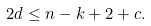Convert formula to latex. <formula><loc_0><loc_0><loc_500><loc_500>2 d \leq n - k + 2 + c .</formula> 